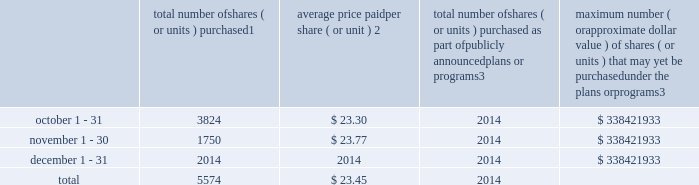Part ii item 5 .
Market for registrant 2019s common equity , related stockholder matters and issuer purchases of equity securities market information our common stock is listed and traded on the new york stock exchange under the symbol 201cipg 201d .
As of february 13 , 2019 , there were approximately 10000 registered holders of our outstanding common stock .
On february 13 , 2019 , we announced that our board of directors ( the 201cboard 201d ) had declared a common stock cash dividend of $ 0.235 per share , payable on march 15 , 2019 to holders of record as of the close of business on march 1 , 2019 .
Although it is the board 2019s current intention to declare and pay future dividends , there can be no assurance that such additional dividends will in fact be declared and paid .
Any and the amount of any such declaration is at the discretion of the board and will depend upon factors such as our earnings , financial position and cash requirements .
Equity compensation plans see item 12 for information about our equity compensation plans .
Transfer agent and registrar for common stock the transfer agent and registrar for our common stock is : computershare shareowner services llc 480 washington boulevard 29th floor jersey city , new jersey 07310 telephone : ( 877 ) 363-6398 sales of unregistered securities not applicable .
Repurchases of equity securities the table provides information regarding our purchases of our equity securities during the period from october 1 , 2018 to december 31 , 2018 .
Total number of shares ( or units ) purchased 1 average price paid per share ( or unit ) 2 total number of shares ( or units ) purchased as part of publicly announced plans or programs 3 maximum number ( or approximate dollar value ) of shares ( or units ) that may yet be purchased under the plans or programs 3 .
1 the total number of shares of our common stock , par value $ 0.10 per share , repurchased were withheld under the terms of grants under employee stock- based compensation plans to offset tax withholding obligations that occurred upon vesting and release of restricted shares ( the 201cwithheld shares 201d ) .
2 the average price per share for each of the months in the fiscal quarter and for the three-month period was calculated by dividing the sum in the applicable period of the aggregate value of the tax withholding obligations by the sum of the number of withheld shares .
3 in february 2017 , the board authorized a share repurchase program to repurchase from time to time up to $ 300.0 million , excluding fees , of our common stock ( the 201c2017 share repurchase program 201d ) .
In february 2018 , the board authorized a share repurchase program to repurchase from time to time up to $ 300.0 million , excluding fees , of our common stock , which was in addition to any amounts remaining under the 2017 share repurchase program .
On july 2 , 2018 , in connection with the announcement of the acxiom acquisition , we announced that share repurchases will be suspended for a period of time in order to reduce the increased debt levels incurred in conjunction with the acquisition , and no shares were repurchased pursuant to the share repurchase programs in the periods reflected .
There are no expiration dates associated with the share repurchase programs. .
What was the potential cash payment for the cash dividend announced that our board of directors in 2019? 
Computations: (10000 * 0.235)
Answer: 2350.0. Part ii item 5 .
Market for registrant 2019s common equity , related stockholder matters and issuer purchases of equity securities market information our common stock is listed and traded on the new york stock exchange under the symbol 201cipg 201d .
As of february 13 , 2019 , there were approximately 10000 registered holders of our outstanding common stock .
On february 13 , 2019 , we announced that our board of directors ( the 201cboard 201d ) had declared a common stock cash dividend of $ 0.235 per share , payable on march 15 , 2019 to holders of record as of the close of business on march 1 , 2019 .
Although it is the board 2019s current intention to declare and pay future dividends , there can be no assurance that such additional dividends will in fact be declared and paid .
Any and the amount of any such declaration is at the discretion of the board and will depend upon factors such as our earnings , financial position and cash requirements .
Equity compensation plans see item 12 for information about our equity compensation plans .
Transfer agent and registrar for common stock the transfer agent and registrar for our common stock is : computershare shareowner services llc 480 washington boulevard 29th floor jersey city , new jersey 07310 telephone : ( 877 ) 363-6398 sales of unregistered securities not applicable .
Repurchases of equity securities the table provides information regarding our purchases of our equity securities during the period from october 1 , 2018 to december 31 , 2018 .
Total number of shares ( or units ) purchased 1 average price paid per share ( or unit ) 2 total number of shares ( or units ) purchased as part of publicly announced plans or programs 3 maximum number ( or approximate dollar value ) of shares ( or units ) that may yet be purchased under the plans or programs 3 .
1 the total number of shares of our common stock , par value $ 0.10 per share , repurchased were withheld under the terms of grants under employee stock- based compensation plans to offset tax withholding obligations that occurred upon vesting and release of restricted shares ( the 201cwithheld shares 201d ) .
2 the average price per share for each of the months in the fiscal quarter and for the three-month period was calculated by dividing the sum in the applicable period of the aggregate value of the tax withholding obligations by the sum of the number of withheld shares .
3 in february 2017 , the board authorized a share repurchase program to repurchase from time to time up to $ 300.0 million , excluding fees , of our common stock ( the 201c2017 share repurchase program 201d ) .
In february 2018 , the board authorized a share repurchase program to repurchase from time to time up to $ 300.0 million , excluding fees , of our common stock , which was in addition to any amounts remaining under the 2017 share repurchase program .
On july 2 , 2018 , in connection with the announcement of the acxiom acquisition , we announced that share repurchases will be suspended for a period of time in order to reduce the increased debt levels incurred in conjunction with the acquisition , and no shares were repurchased pursuant to the share repurchase programs in the periods reflected .
There are no expiration dates associated with the share repurchase programs. .
What was the percentage decrease from october to november on total number of share purchased? 
Computations: (((3824 - 1750) / 3824) * 100)
Answer: 54.2364. Part ii item 5 .
Market for registrant 2019s common equity , related stockholder matters and issuer purchases of equity securities market information our common stock is listed and traded on the new york stock exchange under the symbol 201cipg 201d .
As of february 13 , 2019 , there were approximately 10000 registered holders of our outstanding common stock .
On february 13 , 2019 , we announced that our board of directors ( the 201cboard 201d ) had declared a common stock cash dividend of $ 0.235 per share , payable on march 15 , 2019 to holders of record as of the close of business on march 1 , 2019 .
Although it is the board 2019s current intention to declare and pay future dividends , there can be no assurance that such additional dividends will in fact be declared and paid .
Any and the amount of any such declaration is at the discretion of the board and will depend upon factors such as our earnings , financial position and cash requirements .
Equity compensation plans see item 12 for information about our equity compensation plans .
Transfer agent and registrar for common stock the transfer agent and registrar for our common stock is : computershare shareowner services llc 480 washington boulevard 29th floor jersey city , new jersey 07310 telephone : ( 877 ) 363-6398 sales of unregistered securities not applicable .
Repurchases of equity securities the table provides information regarding our purchases of our equity securities during the period from october 1 , 2018 to december 31 , 2018 .
Total number of shares ( or units ) purchased 1 average price paid per share ( or unit ) 2 total number of shares ( or units ) purchased as part of publicly announced plans or programs 3 maximum number ( or approximate dollar value ) of shares ( or units ) that may yet be purchased under the plans or programs 3 .
1 the total number of shares of our common stock , par value $ 0.10 per share , repurchased were withheld under the terms of grants under employee stock- based compensation plans to offset tax withholding obligations that occurred upon vesting and release of restricted shares ( the 201cwithheld shares 201d ) .
2 the average price per share for each of the months in the fiscal quarter and for the three-month period was calculated by dividing the sum in the applicable period of the aggregate value of the tax withholding obligations by the sum of the number of withheld shares .
3 in february 2017 , the board authorized a share repurchase program to repurchase from time to time up to $ 300.0 million , excluding fees , of our common stock ( the 201c2017 share repurchase program 201d ) .
In february 2018 , the board authorized a share repurchase program to repurchase from time to time up to $ 300.0 million , excluding fees , of our common stock , which was in addition to any amounts remaining under the 2017 share repurchase program .
On july 2 , 2018 , in connection with the announcement of the acxiom acquisition , we announced that share repurchases will be suspended for a period of time in order to reduce the increased debt levels incurred in conjunction with the acquisition , and no shares were repurchased pursuant to the share repurchase programs in the periods reflected .
There are no expiration dates associated with the share repurchase programs. .
What was the percentage of the total number of shares purchased in october? 
Computations: (3824 / 5574)
Answer: 0.68604. 